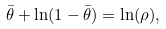<formula> <loc_0><loc_0><loc_500><loc_500>\bar { \theta } + \ln ( 1 - \bar { \theta } ) = \ln ( \rho ) ,</formula> 